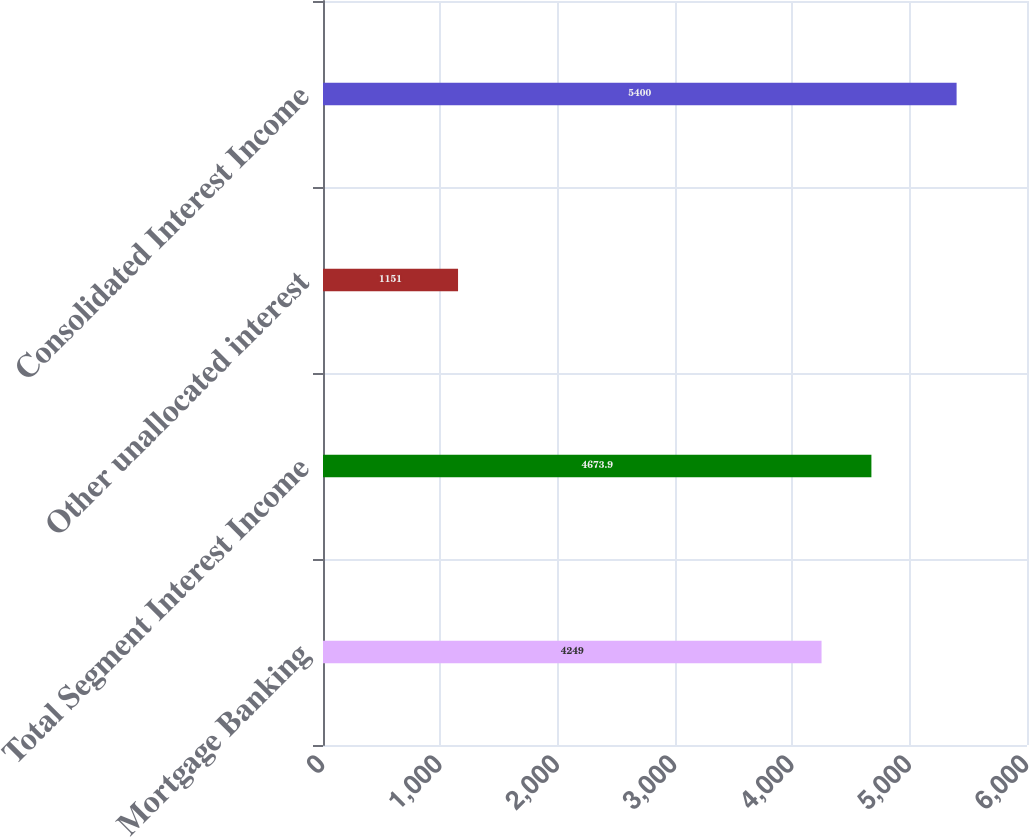Convert chart to OTSL. <chart><loc_0><loc_0><loc_500><loc_500><bar_chart><fcel>Mortgage Banking<fcel>Total Segment Interest Income<fcel>Other unallocated interest<fcel>Consolidated Interest Income<nl><fcel>4249<fcel>4673.9<fcel>1151<fcel>5400<nl></chart> 